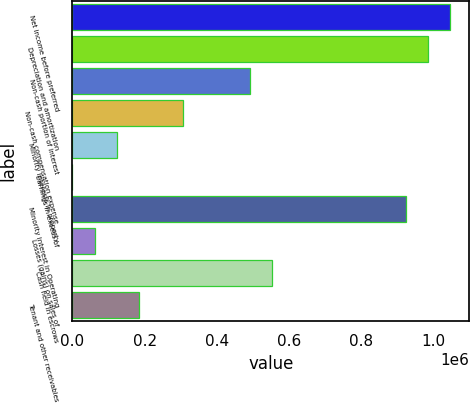Convert chart. <chart><loc_0><loc_0><loc_500><loc_500><bar_chart><fcel>Net income before preferred<fcel>Depreciation and amortization<fcel>Non-cash portion of interest<fcel>Non-cash compensation expense<fcel>Minority interests in property<fcel>Earnings in excess of<fcel>Minority interest in Operating<fcel>Losses (gains) on sales of<fcel>Cash held in escrows<fcel>Tenant and other receivables<nl><fcel>1.04545e+06<fcel>983956<fcel>492023<fcel>307548<fcel>123073<fcel>90<fcel>922464<fcel>61581.6<fcel>553514<fcel>184565<nl></chart> 